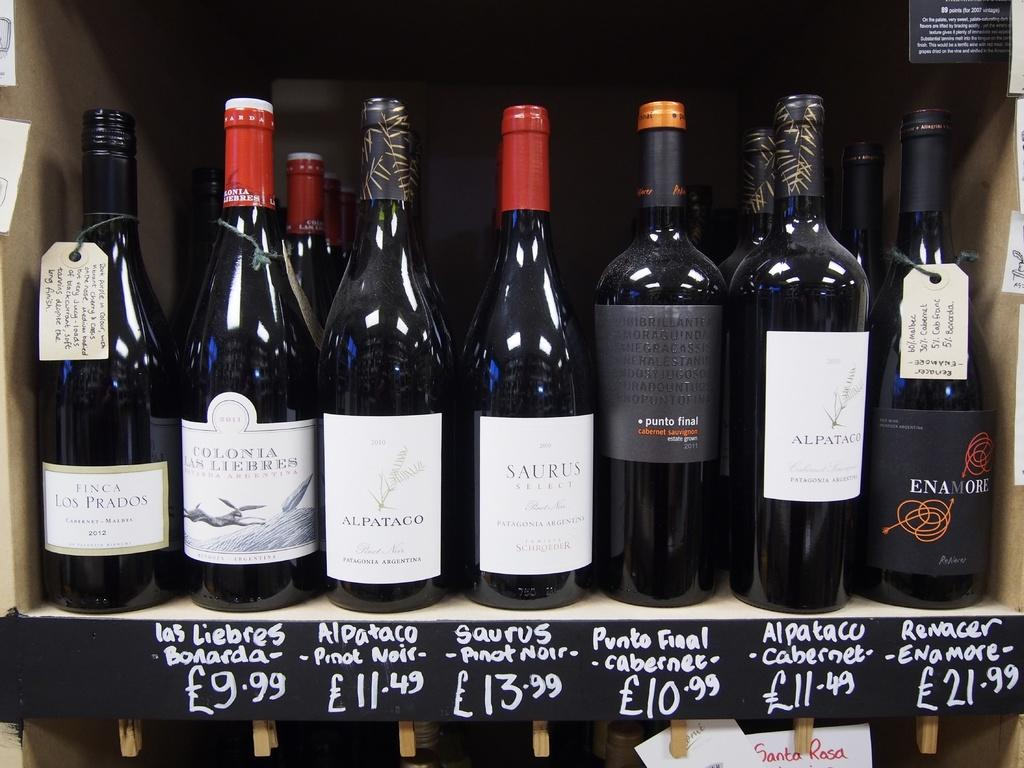<image>
Provide a brief description of the given image. Bottles of wine sit on a shelf with the prices listed underneath them which one says it 10.99 